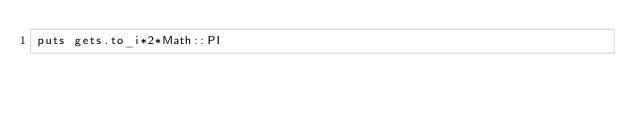Convert code to text. <code><loc_0><loc_0><loc_500><loc_500><_Ruby_>puts gets.to_i*2*Math::PI</code> 